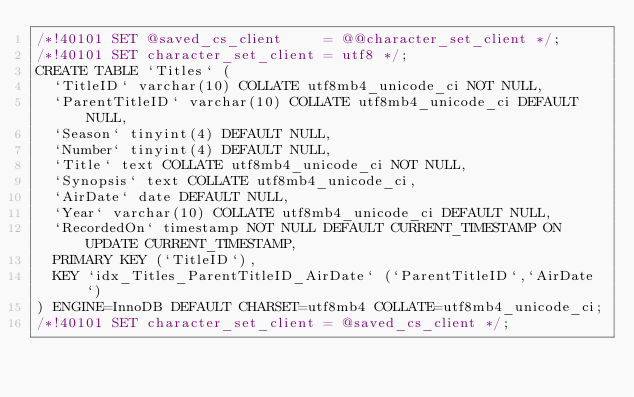<code> <loc_0><loc_0><loc_500><loc_500><_SQL_>/*!40101 SET @saved_cs_client     = @@character_set_client */;
/*!40101 SET character_set_client = utf8 */;
CREATE TABLE `Titles` (
  `TitleID` varchar(10) COLLATE utf8mb4_unicode_ci NOT NULL,
  `ParentTitleID` varchar(10) COLLATE utf8mb4_unicode_ci DEFAULT NULL,
  `Season` tinyint(4) DEFAULT NULL,
  `Number` tinyint(4) DEFAULT NULL,
  `Title` text COLLATE utf8mb4_unicode_ci NOT NULL,
  `Synopsis` text COLLATE utf8mb4_unicode_ci,
  `AirDate` date DEFAULT NULL,
  `Year` varchar(10) COLLATE utf8mb4_unicode_ci DEFAULT NULL,
  `RecordedOn` timestamp NOT NULL DEFAULT CURRENT_TIMESTAMP ON UPDATE CURRENT_TIMESTAMP,
  PRIMARY KEY (`TitleID`),
  KEY `idx_Titles_ParentTitleID_AirDate` (`ParentTitleID`,`AirDate`)
) ENGINE=InnoDB DEFAULT CHARSET=utf8mb4 COLLATE=utf8mb4_unicode_ci;
/*!40101 SET character_set_client = @saved_cs_client */;
</code> 